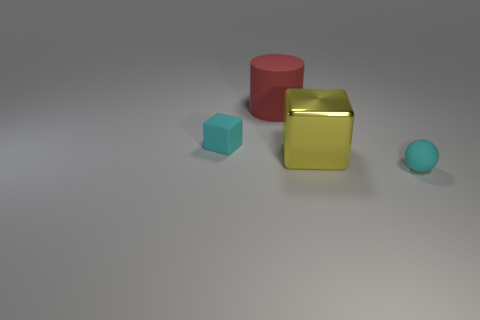There is a red thing that is the same size as the yellow metal thing; what shape is it?
Ensure brevity in your answer.  Cylinder. Is there a rubber object that has the same shape as the large yellow metallic thing?
Give a very brief answer. Yes. How many other big yellow objects are the same material as the yellow object?
Keep it short and to the point. 0. Does the small cyan thing to the right of the big cylinder have the same material as the large yellow block?
Offer a terse response. No. Is the number of yellow objects that are on the left side of the yellow metallic thing greater than the number of cyan rubber cubes that are on the right side of the small cyan ball?
Keep it short and to the point. No. There is a cylinder that is the same size as the yellow object; what is it made of?
Your answer should be compact. Rubber. What number of other things are there of the same material as the small ball
Your response must be concise. 2. There is a big thing that is right of the large red matte cylinder; does it have the same shape as the tiny object that is on the right side of the yellow cube?
Offer a terse response. No. How many other things are there of the same color as the large matte cylinder?
Keep it short and to the point. 0. Is the small object in front of the small cyan cube made of the same material as the tiny cyan thing behind the yellow metallic thing?
Provide a succinct answer. Yes. 